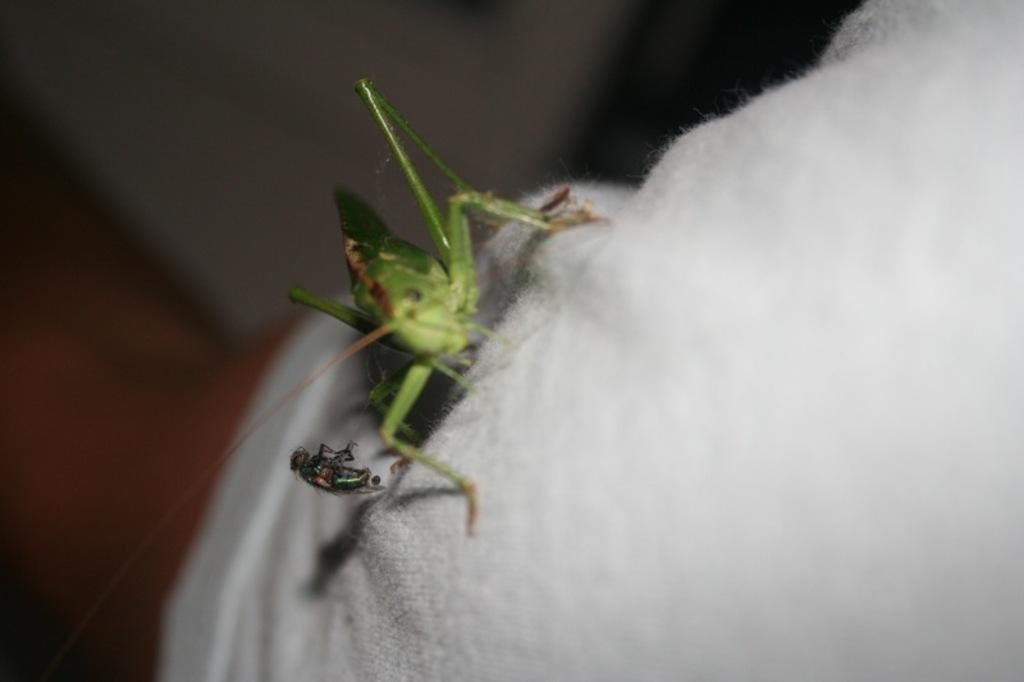Can you describe this image briefly? In this picture we can see two insects on a white cloth and in the background it is blurry. 